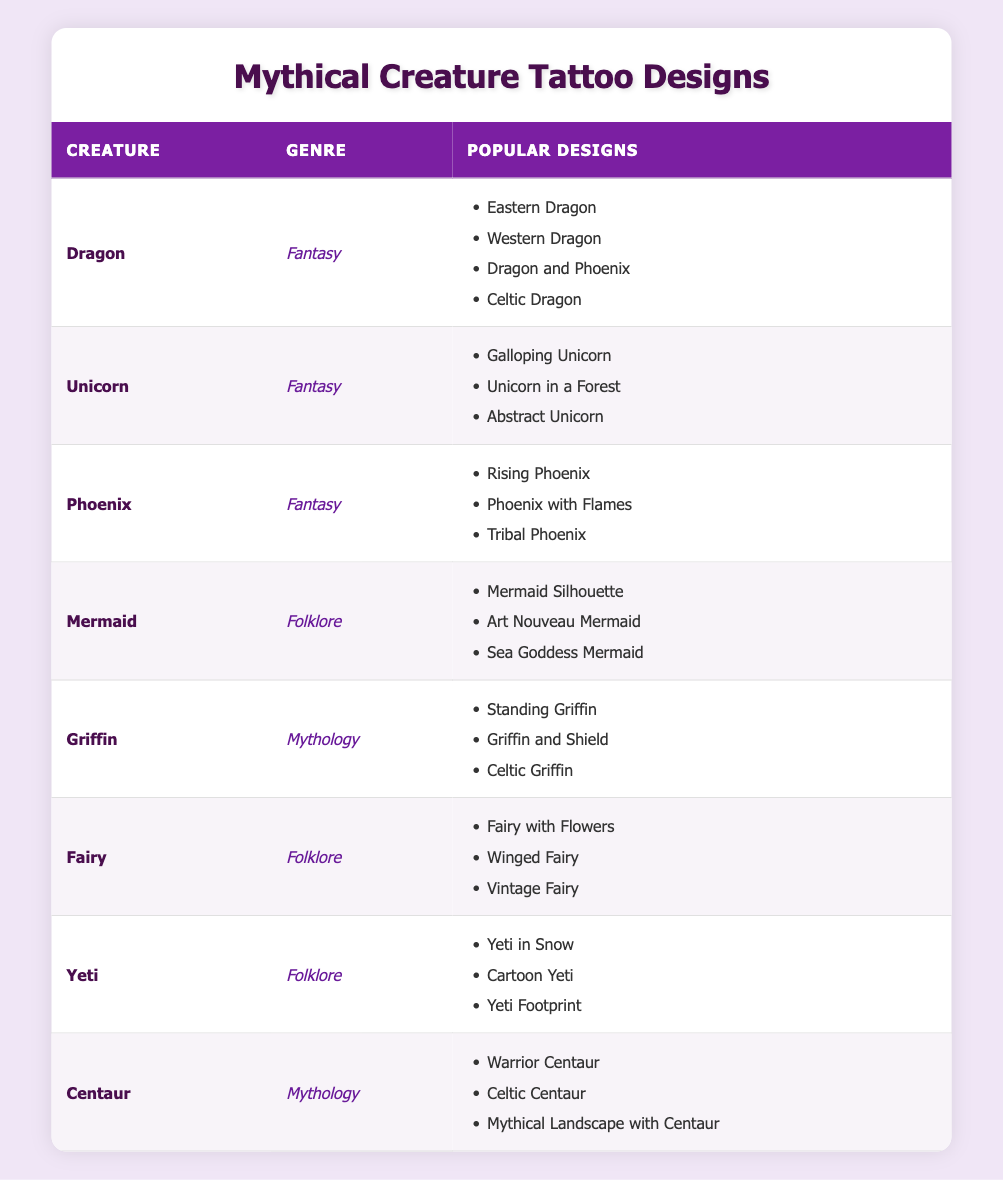What are the popular designs for the Dragon tattoo? To find the answer, refer to the row for the "Dragon" creature in the table, which lists the popular designs: Eastern Dragon, Western Dragon, Dragon and Phoenix, and Celtic Dragon.
Answer: Eastern Dragon, Western Dragon, Dragon and Phoenix, Celtic Dragon Which mythical creature has the most popular designs in the Folklore genre? The Folklore genre includes three creatures: Mermaid, Fairy, and Yeti. Each of these creatures has three popular designs listed, so they are tied.
Answer: Mermaid, Fairy, and Yeti Is "Celtic Griffin" a popular design for Griffin tattoos? Check the row for the Griffin creature in the table. The popular designs include "Standing Griffin," "Griffin and Shield," and "Celtic Griffin," confirming that it is indeed a popular design.
Answer: Yes How many popular designs are there for the Unicorn tattoo? Looking at the row for the Unicorn, it shows three popular designs: Galloping Unicorn, Unicorn in a Forest, and Abstract Unicorn. Thus, there are three designs in total.
Answer: 3 Which creature in the Mythology genre has tattoo designs related to a warrior influence? In the table, the Centaur under the Mythology genre has a popular design named "Warrior Centaur," indicating its relation to a warrior influence.
Answer: Centaur What is the total number of popular designs listed for all creatures combined? Count the designs: Dragon (4) + Unicorn (3) + Phoenix (3) + Mermaid (3) + Griffin (3) + Fairy (3) + Yeti (3) + Centaur (3) = 22 total designs.
Answer: 22 Are there more popular designs for creatures in the Fantasy genre compared to the Folklore genre? The Fantasy genre has three creatures: Dragon (4), Unicorn (3), and Phoenix (3), totaling 10 designs. The Folklore genre has three creatures: Mermaid (3), Fairy (3), and Yeti (3), totaling 9 designs. Since 10 is greater than 9, there are more designs in the Fantasy genre.
Answer: Yes Which genres feature tattoo designs for the creature "Centaur"? The Centaur is listed under the Mythology genre in the table. Therefore, the only genre featuring Centaur designs is Mythology.
Answer: Mythology 